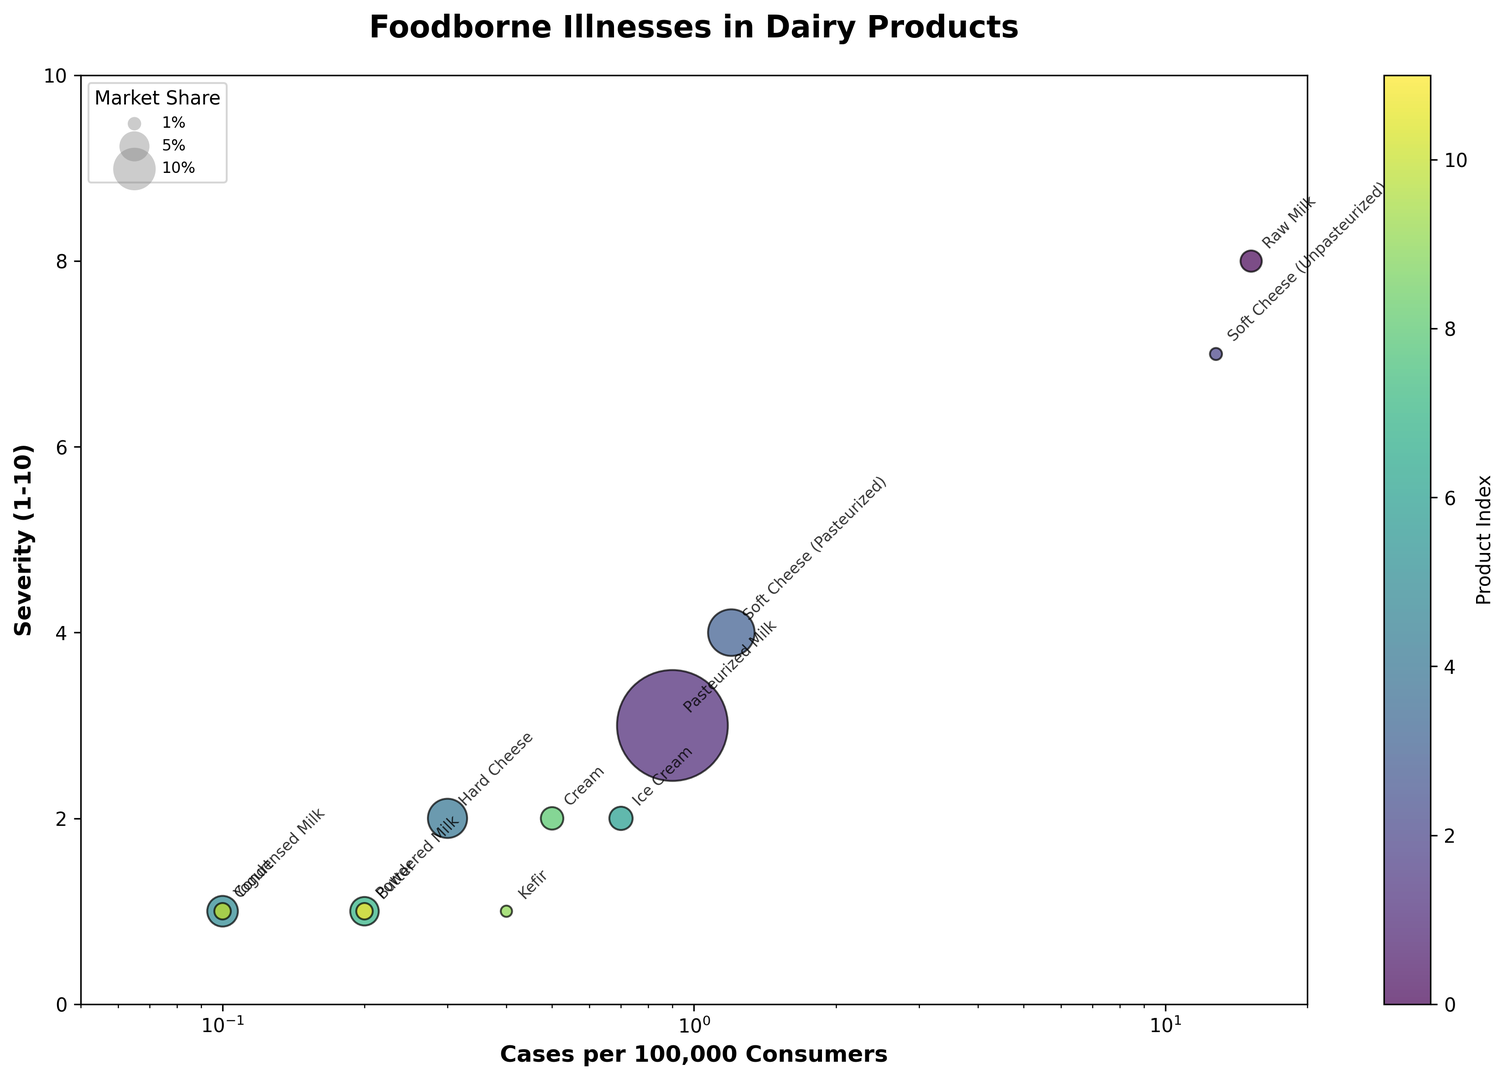What product has the highest number of cases per 100,000 consumers? The figure shows that Raw Milk has the highest value on the x-axis representing the number of cases per 100,000 consumers.
Answer: Raw Milk How does the severity of illnesses caused by Soft Cheese (Unpasteurized) compare to those caused by Pasteurized Milk? Soft Cheese (Unpasteurized) has a severity value of 7, while Pasteurized Milk has a severity value of 3, as indicated by their positions on the vertical axis.
Answer: Higher Among the products with a market share below 1%, which has the lowest number of cases per 100,000 consumers? The figure shows that Kefir and Soft Cheese (Unpasteurized) have a market share below 1%, with Kefir having a lower number of cases per 100,000 consumers compared to Soft Cheese (Unpasteurized).
Answer: Kefir Does any product have both a high severity of illnesses and a high market share? To answer this, identify products with higher values along the y-axis (severity) and substantial bubble sizes, but no large bubble (indicating high market share) is associated with high severity.
Answer: No Rank the top three products in terms of market share. Check the bubble sizes to identify the largest bubbles which represent the highest market shares. They are Pasteurized Milk, Soft Cheese (Pasteurized), and Hard Cheese.
Answer: Pasteurized Milk, Soft Cheese (Pasteurized), Hard Cheese What product has the lowest severity of illnesses, and what is its market share? The product with the lowest position on the y-axis is Yogurt, and its bubble indicates a market share of 5.2%.
Answer: Yogurt, 5.2% Is there a correlation between market share and severity of illnesses? Generally, the larger bubbles (indicating higher market share) tend to be lower on the y-axis (indicating lower severity), suggesting a negative correlation.
Answer: Negative correlation How does the prevalence of foodborne illnesses in Raw Milk compare to Soft Cheese (Unpasteurized)? Raw Milk has 15.2 cases per 100,000 consumers, while Soft Cheese (Unpasteurized) has 12.8 cases, as indicated by their positions on the horizontal axis.
Answer: Higher What is the market share for products with less than 1 case per 100,000 consumers? Products in this category (Yogurt, Condensed Milk, Kefir, Powdered Milk, Butter) have market shares corresponding to their bubble sizes, which are 5.2%, 1.5%, 0.7%, 1.5%, and 4.5%, respectively.
Answer: 5.2%, 1.5%, 0.7%, 1.5%, 4.5% Among products with a severity level above 5, which has the highest market share? Only Raw Milk and Soft Cheese (Unpasteurized) have a severity level above 5, and Soft Cheese (Unpasteurized) has a higher market share compared to Raw Milk.
Answer: Soft Cheese (Unpasteurized) 